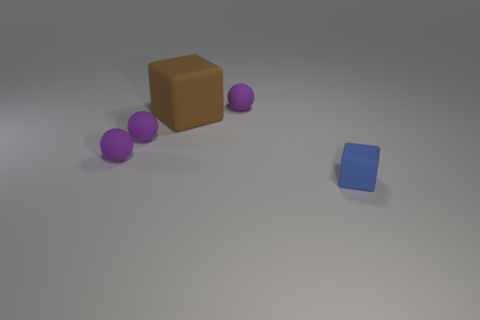There is a large brown thing that is the same material as the tiny blue thing; what is its shape? cube 